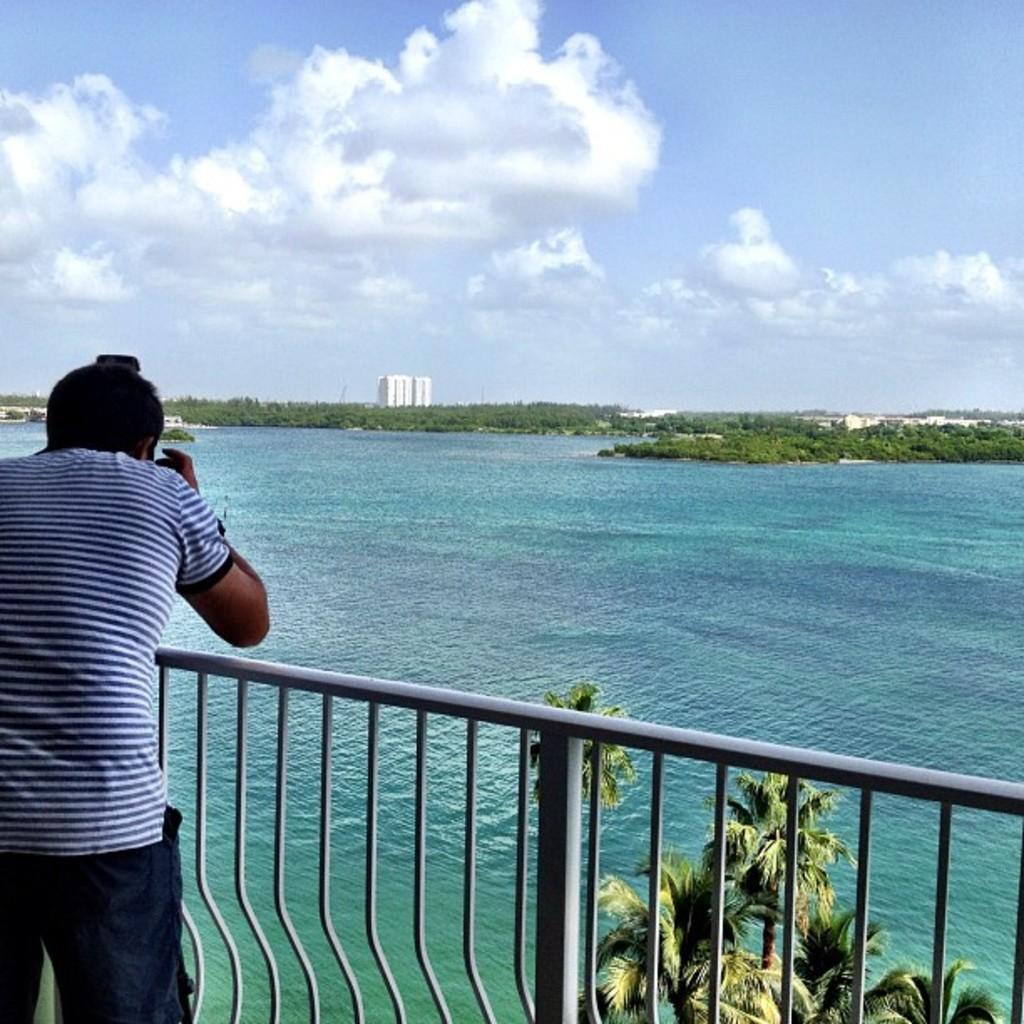Please provide a concise description of this image. In this picture there is a man wearing blue color t-shirt, taking the picture of the nature scene. Behind there is a lake water with some trees and white building. 